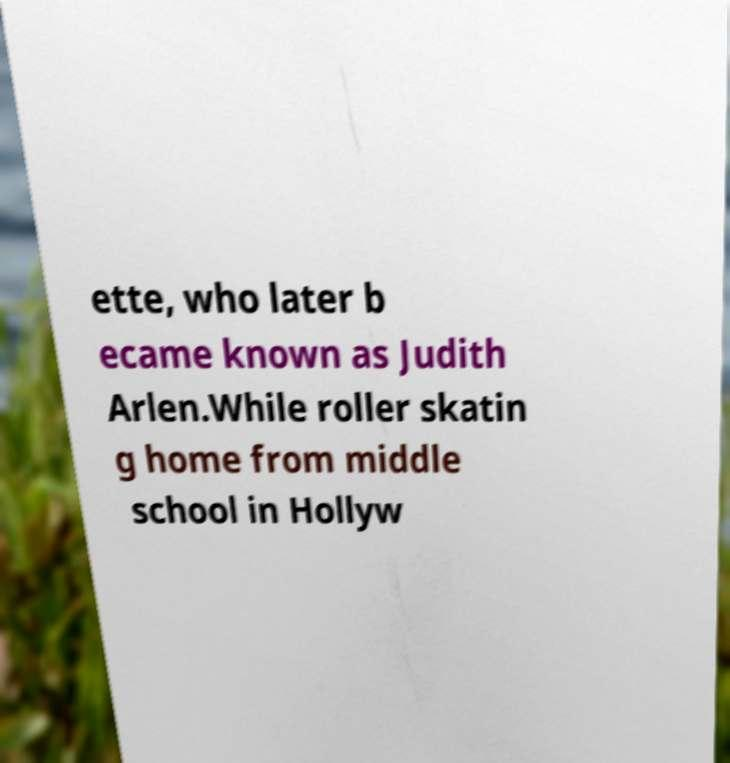Can you accurately transcribe the text from the provided image for me? ette, who later b ecame known as Judith Arlen.While roller skatin g home from middle school in Hollyw 